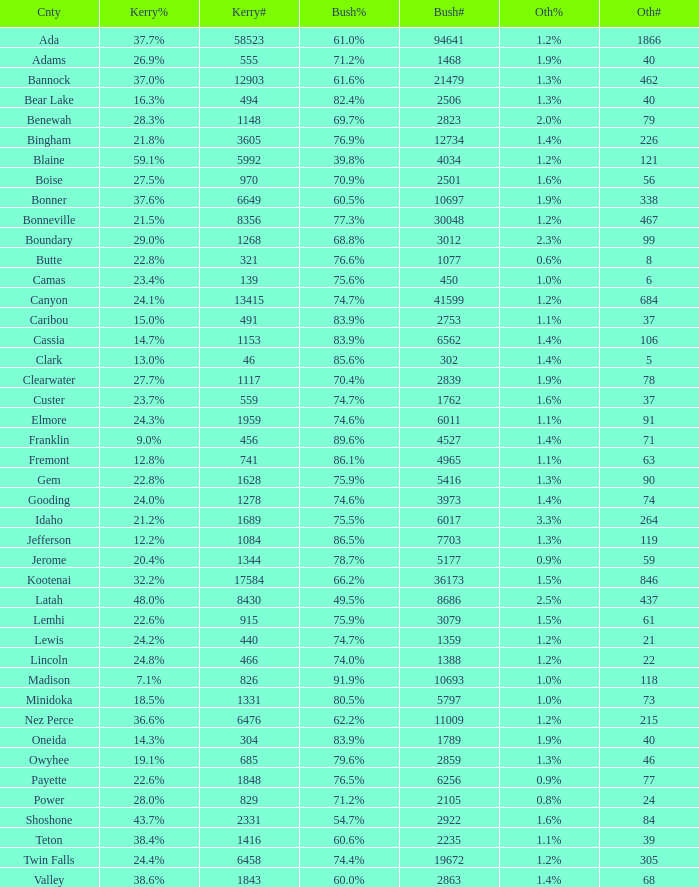What's percentage voted for Busg in the county where Kerry got 37.6%? 60.5%. 